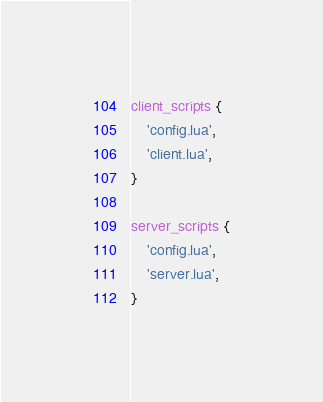<code> <loc_0><loc_0><loc_500><loc_500><_Lua_>
client_scripts {
	'config.lua',
	'client.lua',
}

server_scripts {
	'config.lua',
	'server.lua',
}

</code> 